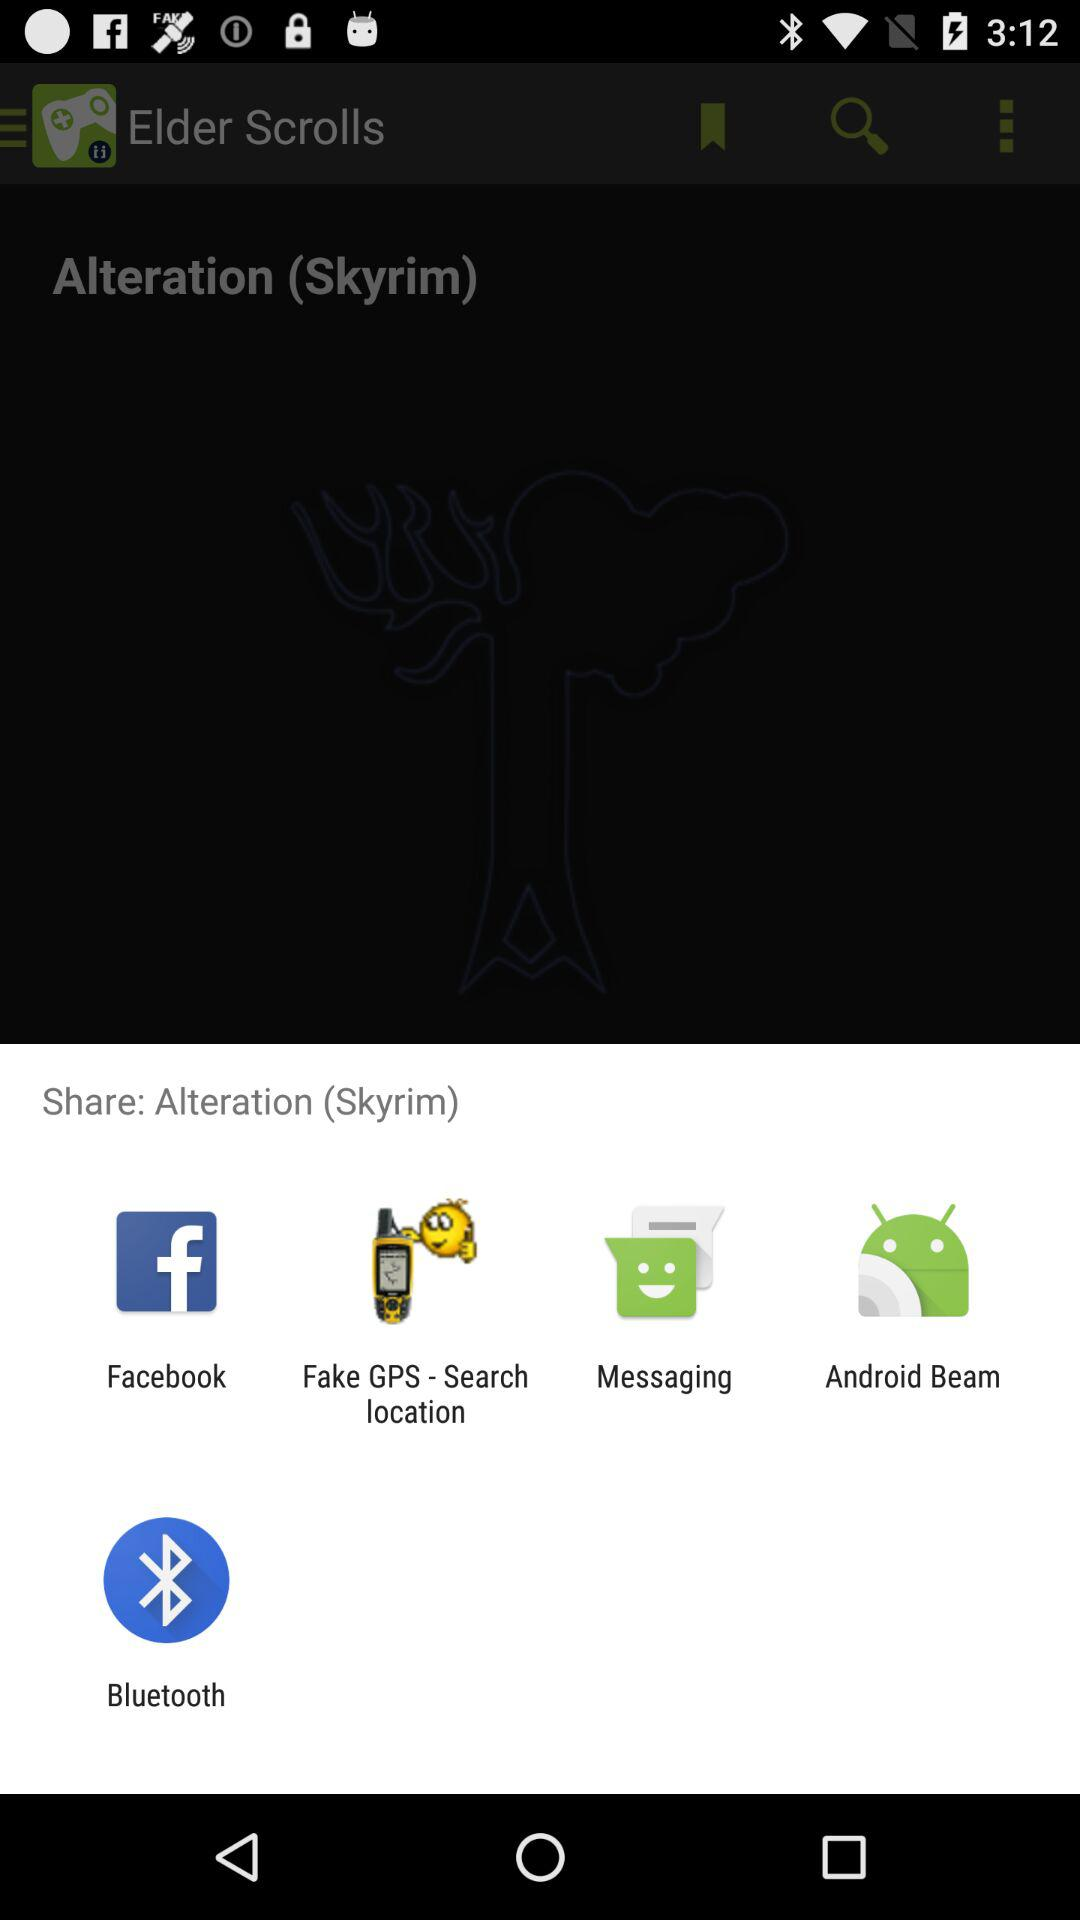What is the different mediums to share? You can share it with "Facebook", "Fake GPS - Search location", "Messaging", "Android Beam" and "Bluetooth". 